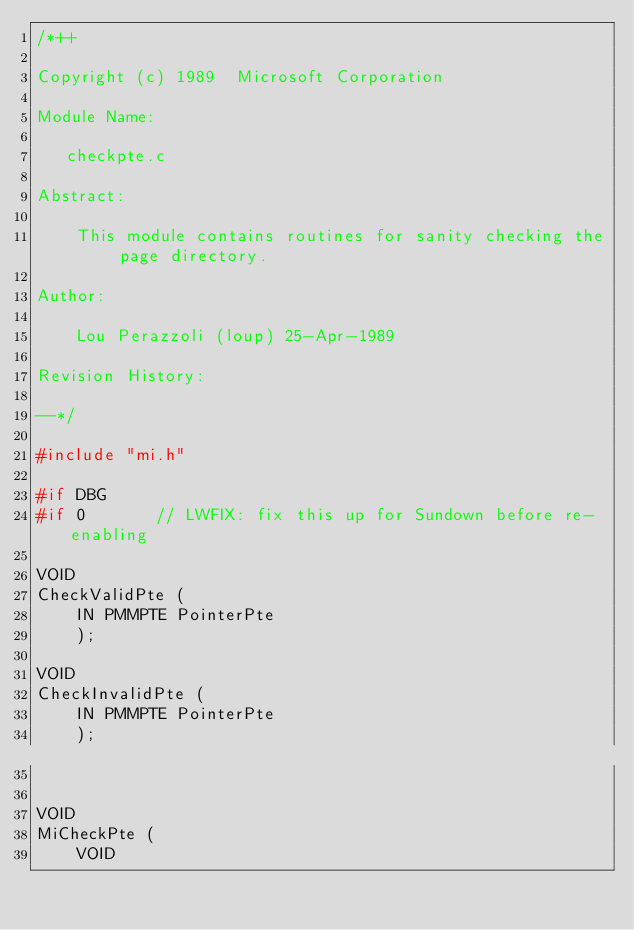<code> <loc_0><loc_0><loc_500><loc_500><_C_>/*++

Copyright (c) 1989  Microsoft Corporation

Module Name:

   checkpte.c

Abstract:

    This module contains routines for sanity checking the page directory.

Author:

    Lou Perazzoli (loup) 25-Apr-1989

Revision History:

--*/

#include "mi.h"

#if DBG
#if 0       // LWFIX: fix this up for Sundown before re-enabling

VOID
CheckValidPte (
    IN PMMPTE PointerPte
    );

VOID
CheckInvalidPte (
    IN PMMPTE PointerPte
    );


VOID
MiCheckPte (
    VOID</code> 